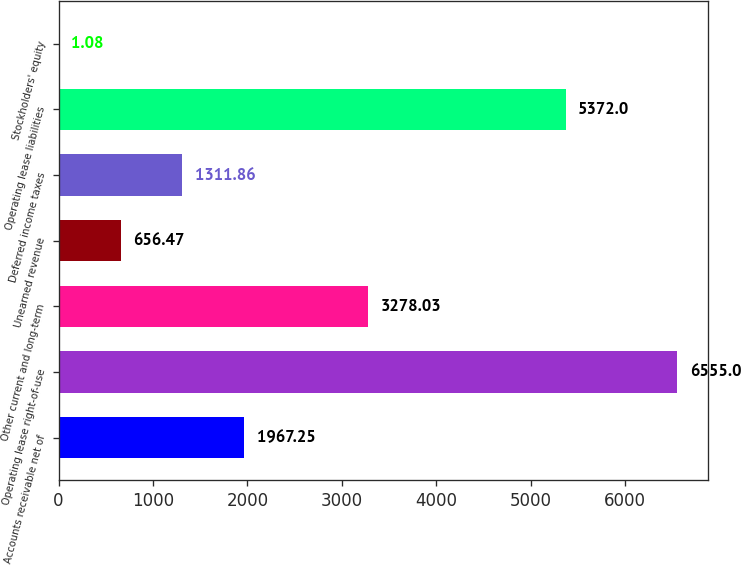Convert chart to OTSL. <chart><loc_0><loc_0><loc_500><loc_500><bar_chart><fcel>Accounts receivable net of<fcel>Operating lease right-of-use<fcel>Other current and long-term<fcel>Unearned revenue<fcel>Deferred income taxes<fcel>Operating lease liabilities<fcel>Stockholders' equity<nl><fcel>1967.25<fcel>6555<fcel>3278.03<fcel>656.47<fcel>1311.86<fcel>5372<fcel>1.08<nl></chart> 